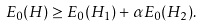Convert formula to latex. <formula><loc_0><loc_0><loc_500><loc_500>E _ { 0 } ( H ) \geq E _ { 0 } ( H _ { 1 } ) + \alpha E _ { 0 } ( H _ { 2 } ) .</formula> 